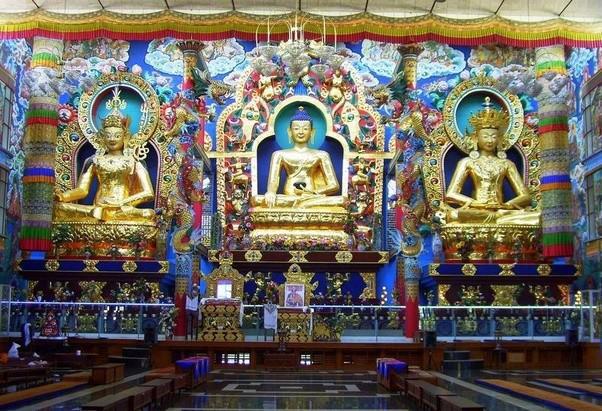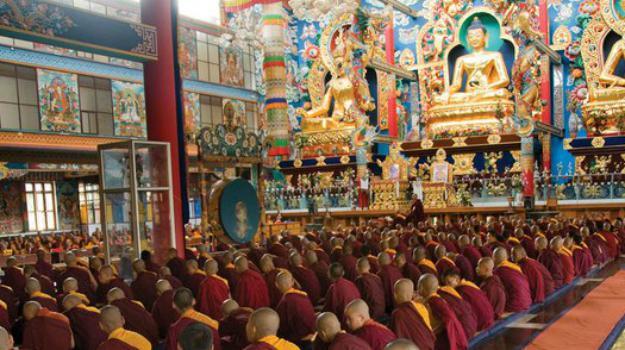The first image is the image on the left, the second image is the image on the right. Assess this claim about the two images: "There are three religious statues in the left image.". Correct or not? Answer yes or no. Yes. The first image is the image on the left, the second image is the image on the right. Examine the images to the left and right. Is the description "The left image features three gold figures in lotus positions side-by-side in a row, with the figures on the ends wearing crowns." accurate? Answer yes or no. Yes. 